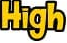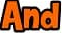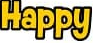What words are shown in these images in order, separated by a semicolon? High; And; Happy 